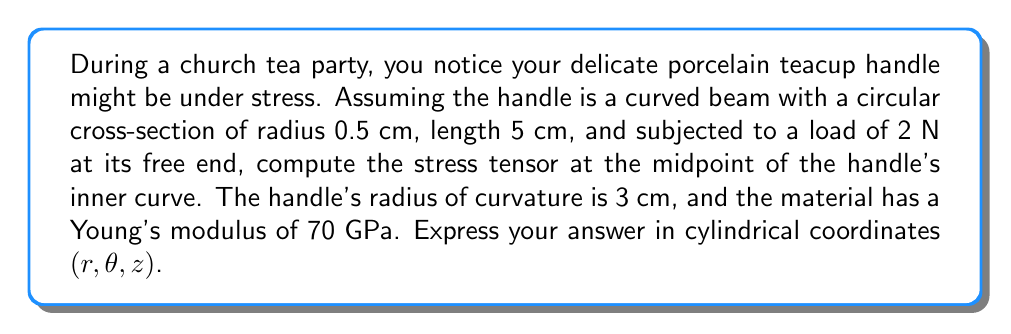Solve this math problem. Let's approach this step-by-step:

1) For a curved beam, the stress tensor in cylindrical coordinates is given by:

   $$\sigma = \begin{pmatrix}
   \sigma_{rr} & \sigma_{r\theta} & \sigma_{rz} \\
   \sigma_{\theta r} & \sigma_{\theta\theta} & \sigma_{\theta z} \\
   \sigma_{zr} & \sigma_{z\theta} & \sigma_{zz}
   \end{pmatrix}$$

2) In this case, the primary stress components are $\sigma_{\theta\theta}$ and $\sigma_{zz}$. Other components are zero due to the nature of the loading.

3) The bending stress $\sigma_{\theta\theta}$ is given by:

   $$\sigma_{\theta\theta} = \frac{My}{I}$$

   Where $M$ is the bending moment, $y$ is the distance from the neutral axis, and $I$ is the moment of inertia.

4) The bending moment $M$ at the midpoint is:

   $$M = \frac{FL}{2} = \frac{2 \text{ N} \times 0.05 \text{ m}}{2} = 0.05 \text{ N·m}$$

5) The moment of inertia for a circular cross-section is:

   $$I = \frac{\pi r^4}{4} = \frac{\pi (0.005 \text{ m})^4}{4} = 4.91 \times 10^{-10} \text{ m}^4$$

6) At the inner curve, $y = -0.005 \text{ m}$ (negative because it's on the inside of the curve)

7) Therefore, $\sigma_{\theta\theta}$ is:

   $$\sigma_{\theta\theta} = \frac{0.05 \text{ N·m} \times (-0.005 \text{ m})}{4.91 \times 10^{-10} \text{ m}^4} = -5.09 \times 10^6 \text{ Pa} = -5.09 \text{ MPa}$$

8) The axial stress $\sigma_{zz}$ due to the force is:

   $$\sigma_{zz} = \frac{F}{A} = \frac{2 \text{ N}}{\pi (0.005 \text{ m})^2} = 2.55 \times 10^4 \text{ Pa} = 0.0255 \text{ MPa}$$

9) Therefore, the stress tensor at the midpoint of the inner curve is:

   $$\sigma = \begin{pmatrix}
   0 & 0 & 0 \\
   0 & -5.09 & 0 \\
   0 & 0 & 0.0255
   \end{pmatrix} \text{ MPa}$$
Answer: $$\sigma = \begin{pmatrix}
0 & 0 & 0 \\
0 & -5.09 & 0 \\
0 & 0 & 0.0255
\end{pmatrix} \text{ MPa}$$ 